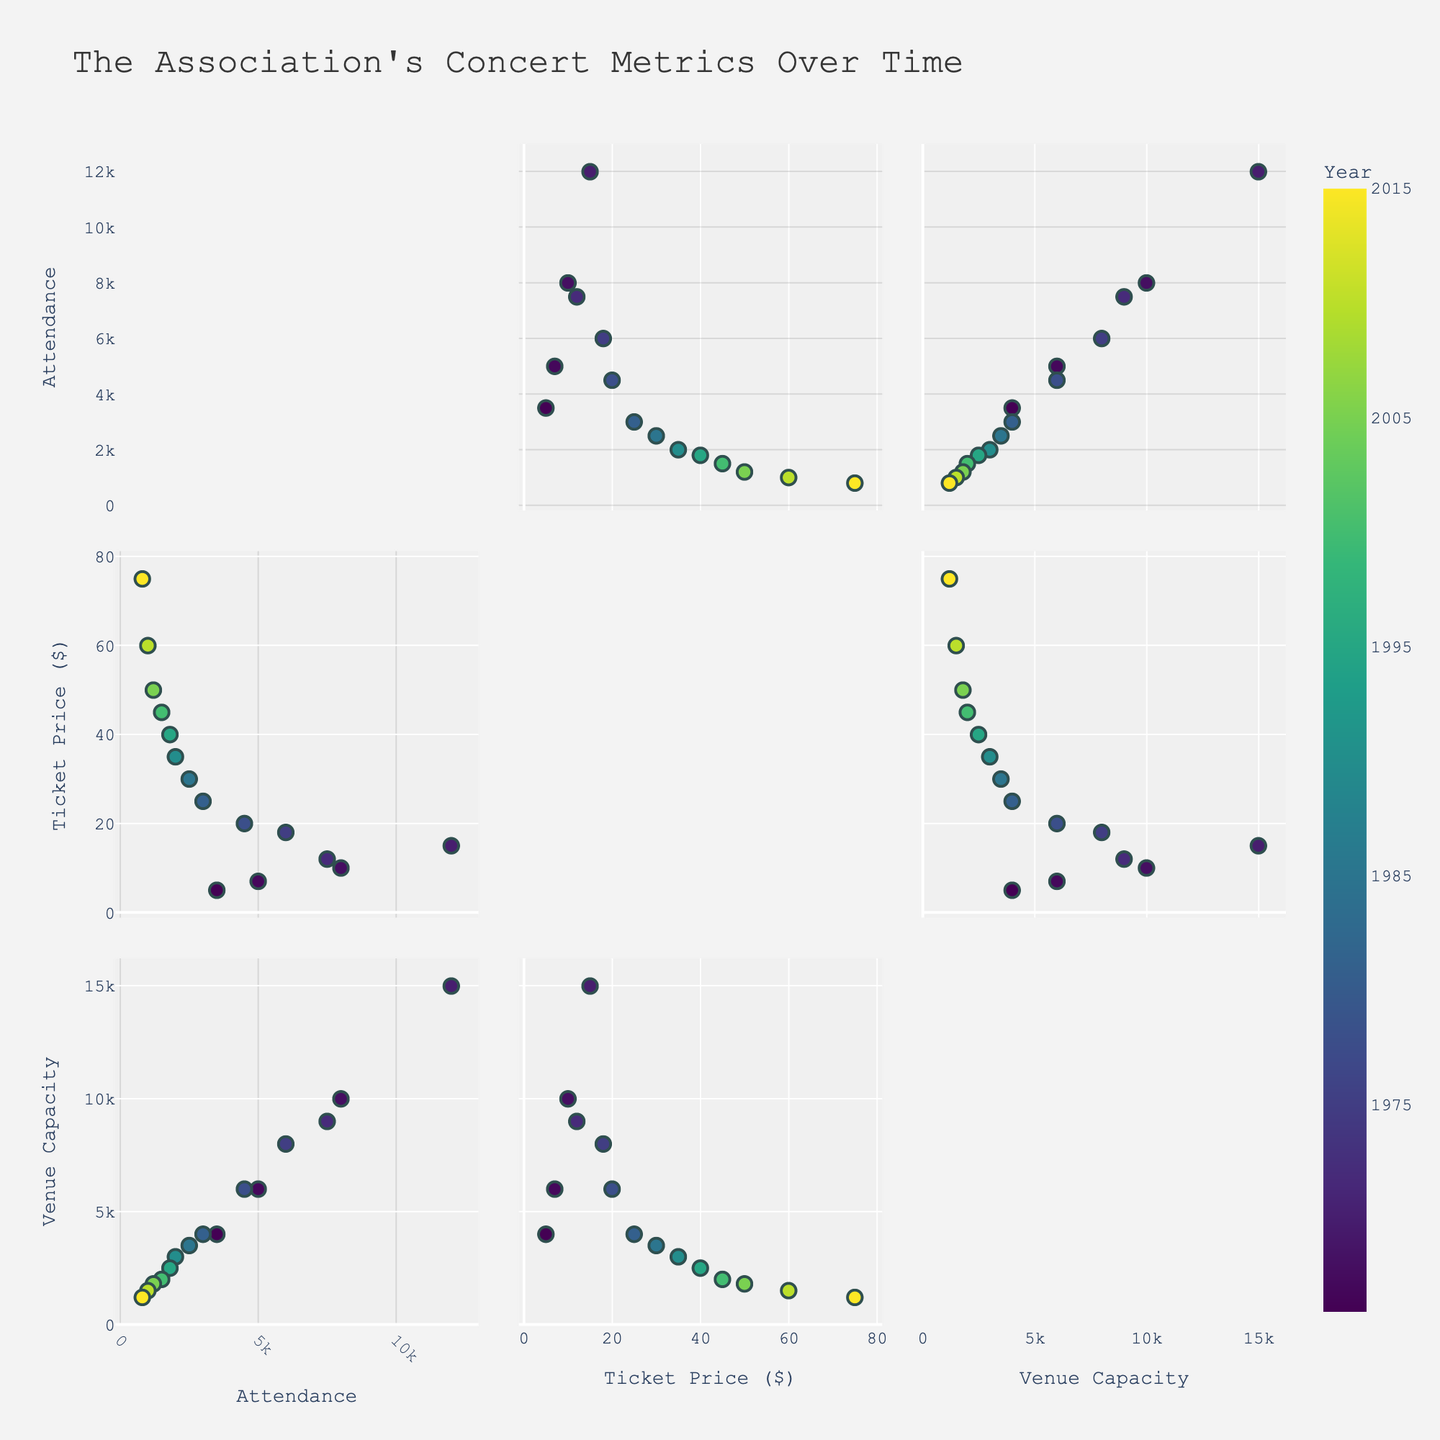What does the figure's title indicate about the data represented? The title "The Association’s Concert Metrics Over Time" indicates that the scatterplot matrix visualizes data on concert attendance, ticket prices, and venue sizes during different years of The Association's career.
Answer: The Association’s Concert Metrics Over Time How are the axes labeled in the scatterplot matrix? The axes of the scatterplot matrix are labeled as "Attendance" for Concert_Attendance, "Ticket Price ($)" for Ticket_Price_USD, and "Venue Capacity" for Venue_Capacity.
Answer: Attendance, Ticket Price ($), Venue Capacity How many data points are represented for each dimension (Concert_Attendance, Ticket_Price_USD, Venue_Capacity) in the scatterplot matrix? Each dimension (Concert_Attendance, Ticket_Price_USD, Venue_Capacity) has 15 data points, one for each year included in the dataset.
Answer: 15 What is the range of ticket prices shown in the scatterplot matrix? The ticket prices range from $5 in 1966 to $75 in 2015, as seen in the scatter plot against the years.
Answer: $5 to $75 Which year had the highest concert attendance, and what was the attendance number? Looking at the scatterplots, the highest concert attendance was in 1970, with approximately 12,000 attendees.
Answer: 1970, 12,000 attendees What is the relationship between concert attendance and ticket price over the years? The scatterplot matrix shows that as ticket prices increased, concert attendance generally decreased over the years, indicating an inverse relationship between these variables.
Answer: Inverse relationship What is the comparative venue capacity in 1970 and 1985? By referring to the scatterplot matrix, the venue capacity in 1970 was 15,000, while in 1985, it was 3,500.
Answer: 1970: 15,000; 1985: 3,500 Which year had the smallest venue capacity, and what was the capacity? The smallest venue capacity was in 2015, with a capacity of 1,200.
Answer: 2015, 1,200 How does concert attendance relate to venue capacity over time? Reviewing the scatterplots, there is a general trend showing that higher venue capacities are associated with higher concert attendance, especially noticeable in earlier years.
Answer: Higher venue capacity, higher attendance Does the color scale used in the scatterplot matrix gradually change over time? Yes, the color gradient in the scatterplot matrix follows the "Viridis" scale, which changes progressively from one year to the next, making it easy to observe the passage of time visually.
Answer: Yes 